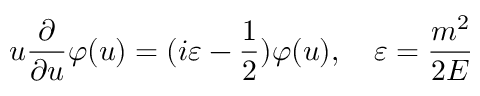<formula> <loc_0><loc_0><loc_500><loc_500>u \frac { \partial } { \partial u } \varphi ( u ) = ( i \varepsilon - \frac { 1 } { 2 } ) \varphi ( u ) , \quad \varepsilon = \frac { m ^ { 2 } } { 2 E }</formula> 